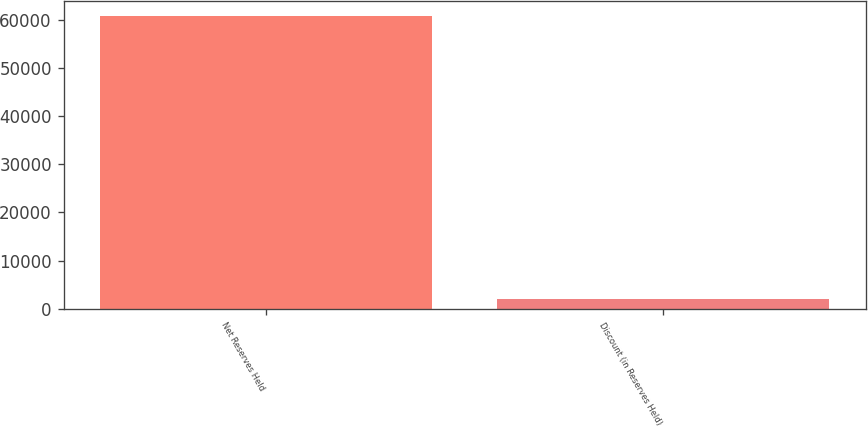Convert chart to OTSL. <chart><loc_0><loc_0><loc_500><loc_500><bar_chart><fcel>Net Reserves Held<fcel>Discount (in Reserves Held)<nl><fcel>60749.7<fcel>2110<nl></chart> 